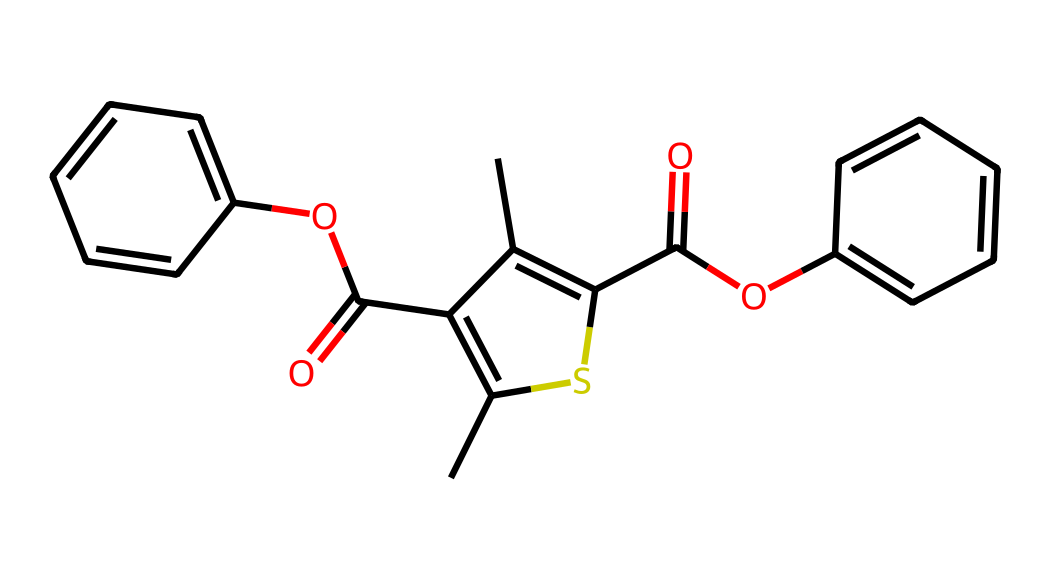What is the molecular formula of this compound? The molecular formula can be derived by counting the number of each type of atom present in the chemical structure represented by the SMILES notation. For this molecule, there are 20 carbon (C) atoms, 16 hydrogen (H) atoms, and 4 oxygen (O) atoms. The molecular formula is thus C20H16O4.
Answer: C20H16O4 How many aromatic rings are present in the structure? By analyzing the SMILES notation, we can identify aromatic rings, which are typically represented by benzene-like structures. In this case, there are two benzene rings within the structure, indicating that it contains a total of two aromatic rings.
Answer: 2 Which functional groups are present in the molecule? Examining the structure shows the presence of ester (C(=O)O) functional groups indicated by the C=O followed by an oxygen atom attached to a carbon chain. Additionally, there are ketones (C(=O)) shown within the molecular framework. Therefore, the main functional groups present are esters and ketones.
Answer: esters and ketones What is the count of sulfur atoms in this molecule? The SMILES representation indicates the presence of a single sulfur atom as a part of a thiophene ring. Counting the occurrences shows that exactly one sulfur atom is present in the overall structure of the molecule.
Answer: 1 Is this compound likely to be conductive based on its structure? Conductivity in polymers generally arises from delocalized π-electrons, often facilitated by conjugated systems. This compound contains multiple aromatic rings and functional groups conducive to electron mobility, suggesting that it likely exhibits conductive properties.
Answer: likely What type of polymer can this chemical form? Given the presence of aromatic structures and functional groups that support polymerization, this compound likely forms conductive polymers such as polythiophenes or phenylene-based conductive materials. Its ability to undergo additional reactions suggests it can create conjugated systems typical of conductive polymers.
Answer: conductive polymer 